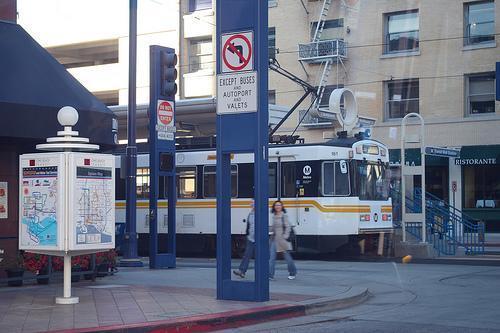How many people are there?
Give a very brief answer. 2. 